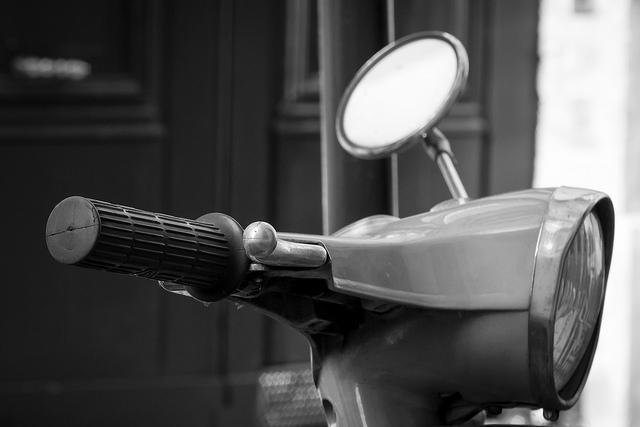Is the light on?
Short answer required. No. What color is the handle in this picture?
Short answer required. Black. Is there a side-mirror above the light?
Give a very brief answer. Yes. 